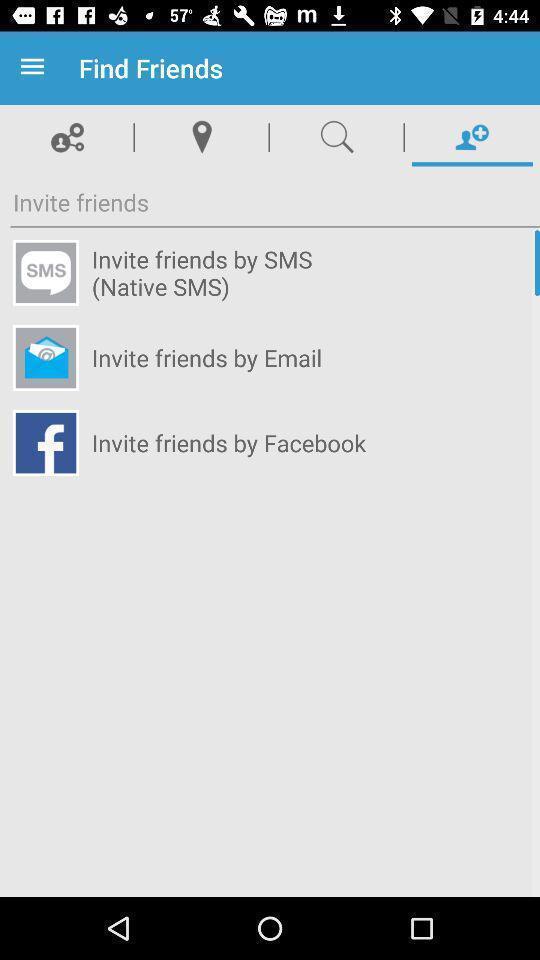Give me a narrative description of this picture. Screen displaying options to find friends in a social app. 